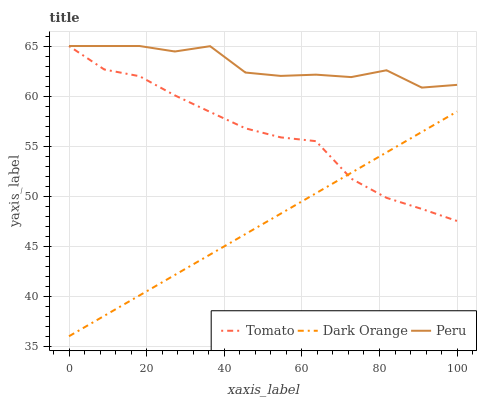Does Dark Orange have the minimum area under the curve?
Answer yes or no. Yes. Does Peru have the maximum area under the curve?
Answer yes or no. Yes. Does Peru have the minimum area under the curve?
Answer yes or no. No. Does Dark Orange have the maximum area under the curve?
Answer yes or no. No. Is Dark Orange the smoothest?
Answer yes or no. Yes. Is Peru the roughest?
Answer yes or no. Yes. Is Peru the smoothest?
Answer yes or no. No. Is Dark Orange the roughest?
Answer yes or no. No. Does Dark Orange have the lowest value?
Answer yes or no. Yes. Does Peru have the lowest value?
Answer yes or no. No. Does Peru have the highest value?
Answer yes or no. Yes. Does Dark Orange have the highest value?
Answer yes or no. No. Is Dark Orange less than Peru?
Answer yes or no. Yes. Is Peru greater than Dark Orange?
Answer yes or no. Yes. Does Tomato intersect Peru?
Answer yes or no. Yes. Is Tomato less than Peru?
Answer yes or no. No. Is Tomato greater than Peru?
Answer yes or no. No. Does Dark Orange intersect Peru?
Answer yes or no. No. 